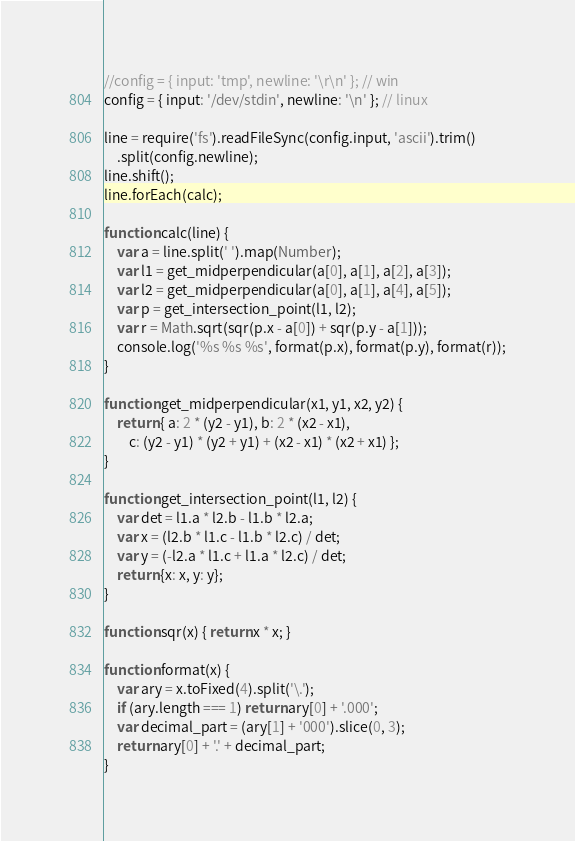Convert code to text. <code><loc_0><loc_0><loc_500><loc_500><_JavaScript_>//config = { input: 'tmp', newline: '\r\n' }; // win
config = { input: '/dev/stdin', newline: '\n' }; // linux

line = require('fs').readFileSync(config.input, 'ascii').trim()
	.split(config.newline);
line.shift();
line.forEach(calc);

function calc(line) {
	var a = line.split(' ').map(Number);
	var l1 = get_midperpendicular(a[0], a[1], a[2], a[3]);
	var l2 = get_midperpendicular(a[0], a[1], a[4], a[5]);
	var p = get_intersection_point(l1, l2);
	var r = Math.sqrt(sqr(p.x - a[0]) + sqr(p.y - a[1]));
	console.log('%s %s %s', format(p.x), format(p.y), format(r));
}

function get_midperpendicular(x1, y1, x2, y2) {
	return { a: 2 * (y2 - y1), b: 2 * (x2 - x1),
		c: (y2 - y1) * (y2 + y1) + (x2 - x1) * (x2 + x1) };
}

function get_intersection_point(l1, l2) {
	var det = l1.a * l2.b - l1.b * l2.a;
	var x = (l2.b * l1.c - l1.b * l2.c) / det;
	var y = (-l2.a * l1.c + l1.a * l2.c) / det;
	return {x: x, y: y};
}

function sqr(x) { return x * x; }

function format(x) {
	var ary = x.toFixed(4).split('\.');
	if (ary.length === 1) return ary[0] + '.000';
	var decimal_part = (ary[1] + '000').slice(0, 3);
	return ary[0] + '.' + decimal_part;
}</code> 